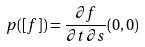<formula> <loc_0><loc_0><loc_500><loc_500>p ( [ f ] ) = \frac { \partial f } { \partial t \partial s } ( 0 , 0 )</formula> 